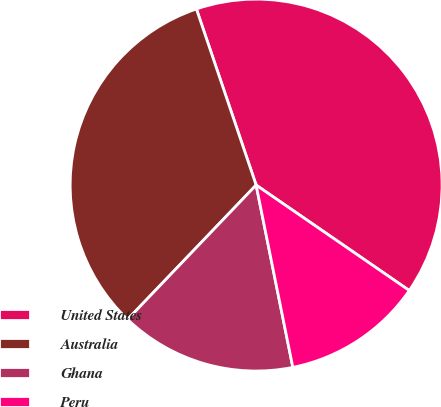Convert chart to OTSL. <chart><loc_0><loc_0><loc_500><loc_500><pie_chart><fcel>United States<fcel>Australia<fcel>Ghana<fcel>Peru<nl><fcel>39.8%<fcel>32.65%<fcel>15.31%<fcel>12.24%<nl></chart> 